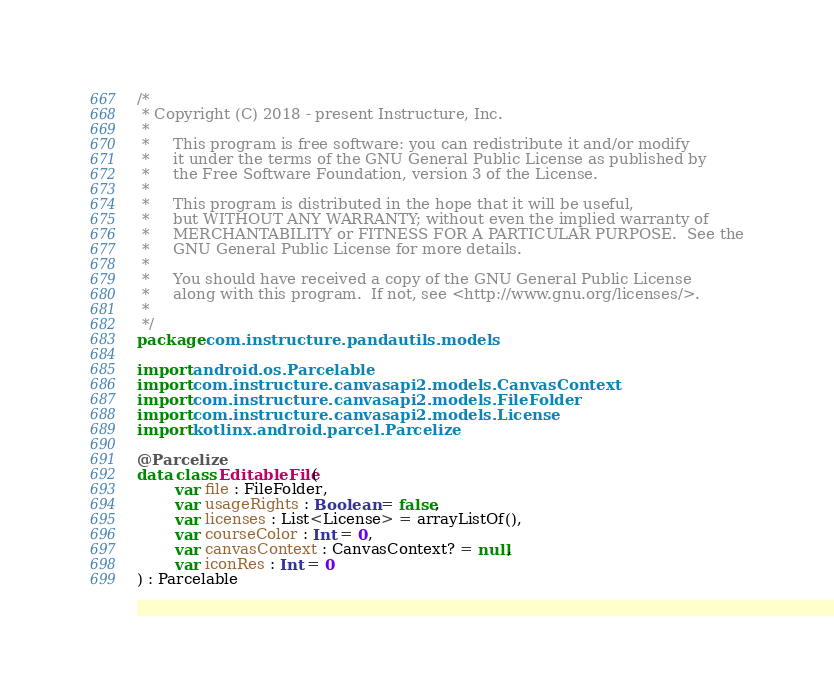<code> <loc_0><loc_0><loc_500><loc_500><_Kotlin_>/*
 * Copyright (C) 2018 - present Instructure, Inc.
 *
 *     This program is free software: you can redistribute it and/or modify
 *     it under the terms of the GNU General Public License as published by
 *     the Free Software Foundation, version 3 of the License.
 *
 *     This program is distributed in the hope that it will be useful,
 *     but WITHOUT ANY WARRANTY; without even the implied warranty of
 *     MERCHANTABILITY or FITNESS FOR A PARTICULAR PURPOSE.  See the
 *     GNU General Public License for more details.
 *
 *     You should have received a copy of the GNU General Public License
 *     along with this program.  If not, see <http://www.gnu.org/licenses/>.
 *
 */
package com.instructure.pandautils.models

import android.os.Parcelable
import com.instructure.canvasapi2.models.CanvasContext
import com.instructure.canvasapi2.models.FileFolder
import com.instructure.canvasapi2.models.License
import kotlinx.android.parcel.Parcelize

@Parcelize
data class EditableFile(
        var file : FileFolder,
        var usageRights : Boolean = false,
        var licenses : List<License> = arrayListOf(),
        var courseColor : Int = 0,
        var canvasContext : CanvasContext? = null,
        var iconRes : Int = 0
) : Parcelable
</code> 